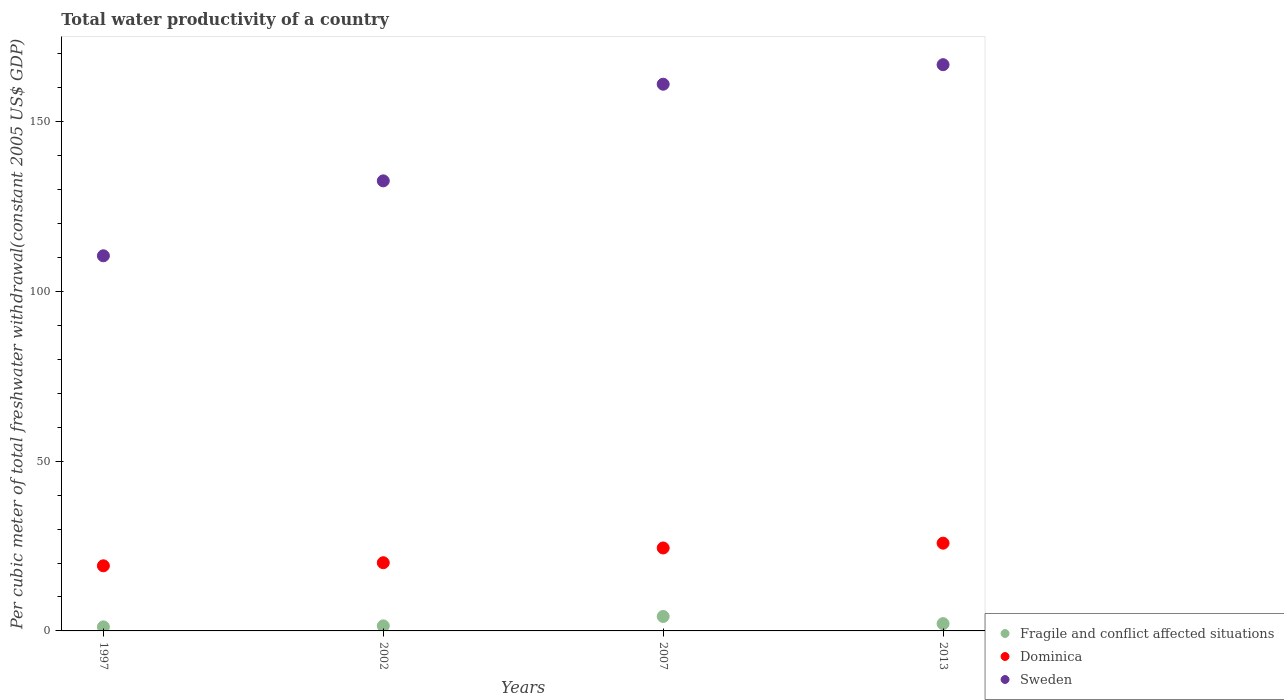What is the total water productivity in Sweden in 2002?
Your answer should be compact. 132.53. Across all years, what is the maximum total water productivity in Fragile and conflict affected situations?
Provide a short and direct response. 4.26. Across all years, what is the minimum total water productivity in Fragile and conflict affected situations?
Give a very brief answer. 1.2. In which year was the total water productivity in Fragile and conflict affected situations minimum?
Make the answer very short. 1997. What is the total total water productivity in Fragile and conflict affected situations in the graph?
Offer a very short reply. 9.08. What is the difference between the total water productivity in Sweden in 1997 and that in 2002?
Offer a very short reply. -22.07. What is the difference between the total water productivity in Fragile and conflict affected situations in 2002 and the total water productivity in Dominica in 1997?
Your response must be concise. -17.69. What is the average total water productivity in Dominica per year?
Make the answer very short. 22.38. In the year 2002, what is the difference between the total water productivity in Dominica and total water productivity in Sweden?
Provide a short and direct response. -112.45. What is the ratio of the total water productivity in Sweden in 2002 to that in 2007?
Keep it short and to the point. 0.82. Is the difference between the total water productivity in Dominica in 2002 and 2007 greater than the difference between the total water productivity in Sweden in 2002 and 2007?
Keep it short and to the point. Yes. What is the difference between the highest and the second highest total water productivity in Fragile and conflict affected situations?
Ensure brevity in your answer.  2.11. What is the difference between the highest and the lowest total water productivity in Dominica?
Your response must be concise. 6.66. In how many years, is the total water productivity in Dominica greater than the average total water productivity in Dominica taken over all years?
Ensure brevity in your answer.  2. Is it the case that in every year, the sum of the total water productivity in Fragile and conflict affected situations and total water productivity in Dominica  is greater than the total water productivity in Sweden?
Your answer should be very brief. No. Is the total water productivity in Dominica strictly greater than the total water productivity in Fragile and conflict affected situations over the years?
Offer a terse response. Yes. What is the difference between two consecutive major ticks on the Y-axis?
Your answer should be very brief. 50. Are the values on the major ticks of Y-axis written in scientific E-notation?
Offer a terse response. No. Where does the legend appear in the graph?
Ensure brevity in your answer.  Bottom right. What is the title of the graph?
Offer a terse response. Total water productivity of a country. What is the label or title of the Y-axis?
Provide a succinct answer. Per cubic meter of total freshwater withdrawal(constant 2005 US$ GDP). What is the Per cubic meter of total freshwater withdrawal(constant 2005 US$ GDP) of Fragile and conflict affected situations in 1997?
Your response must be concise. 1.2. What is the Per cubic meter of total freshwater withdrawal(constant 2005 US$ GDP) of Dominica in 1997?
Provide a short and direct response. 19.18. What is the Per cubic meter of total freshwater withdrawal(constant 2005 US$ GDP) of Sweden in 1997?
Your answer should be very brief. 110.46. What is the Per cubic meter of total freshwater withdrawal(constant 2005 US$ GDP) in Fragile and conflict affected situations in 2002?
Provide a short and direct response. 1.49. What is the Per cubic meter of total freshwater withdrawal(constant 2005 US$ GDP) of Dominica in 2002?
Offer a very short reply. 20.08. What is the Per cubic meter of total freshwater withdrawal(constant 2005 US$ GDP) in Sweden in 2002?
Ensure brevity in your answer.  132.53. What is the Per cubic meter of total freshwater withdrawal(constant 2005 US$ GDP) of Fragile and conflict affected situations in 2007?
Give a very brief answer. 4.26. What is the Per cubic meter of total freshwater withdrawal(constant 2005 US$ GDP) in Dominica in 2007?
Keep it short and to the point. 24.42. What is the Per cubic meter of total freshwater withdrawal(constant 2005 US$ GDP) in Sweden in 2007?
Offer a very short reply. 160.99. What is the Per cubic meter of total freshwater withdrawal(constant 2005 US$ GDP) of Fragile and conflict affected situations in 2013?
Your answer should be compact. 2.14. What is the Per cubic meter of total freshwater withdrawal(constant 2005 US$ GDP) in Dominica in 2013?
Keep it short and to the point. 25.84. What is the Per cubic meter of total freshwater withdrawal(constant 2005 US$ GDP) of Sweden in 2013?
Your response must be concise. 166.74. Across all years, what is the maximum Per cubic meter of total freshwater withdrawal(constant 2005 US$ GDP) of Fragile and conflict affected situations?
Offer a very short reply. 4.26. Across all years, what is the maximum Per cubic meter of total freshwater withdrawal(constant 2005 US$ GDP) in Dominica?
Your response must be concise. 25.84. Across all years, what is the maximum Per cubic meter of total freshwater withdrawal(constant 2005 US$ GDP) in Sweden?
Keep it short and to the point. 166.74. Across all years, what is the minimum Per cubic meter of total freshwater withdrawal(constant 2005 US$ GDP) of Fragile and conflict affected situations?
Provide a short and direct response. 1.2. Across all years, what is the minimum Per cubic meter of total freshwater withdrawal(constant 2005 US$ GDP) in Dominica?
Your response must be concise. 19.18. Across all years, what is the minimum Per cubic meter of total freshwater withdrawal(constant 2005 US$ GDP) of Sweden?
Make the answer very short. 110.46. What is the total Per cubic meter of total freshwater withdrawal(constant 2005 US$ GDP) of Fragile and conflict affected situations in the graph?
Keep it short and to the point. 9.08. What is the total Per cubic meter of total freshwater withdrawal(constant 2005 US$ GDP) of Dominica in the graph?
Provide a succinct answer. 89.53. What is the total Per cubic meter of total freshwater withdrawal(constant 2005 US$ GDP) in Sweden in the graph?
Offer a terse response. 570.73. What is the difference between the Per cubic meter of total freshwater withdrawal(constant 2005 US$ GDP) of Fragile and conflict affected situations in 1997 and that in 2002?
Provide a succinct answer. -0.29. What is the difference between the Per cubic meter of total freshwater withdrawal(constant 2005 US$ GDP) of Dominica in 1997 and that in 2002?
Your response must be concise. -0.91. What is the difference between the Per cubic meter of total freshwater withdrawal(constant 2005 US$ GDP) in Sweden in 1997 and that in 2002?
Your answer should be compact. -22.07. What is the difference between the Per cubic meter of total freshwater withdrawal(constant 2005 US$ GDP) of Fragile and conflict affected situations in 1997 and that in 2007?
Ensure brevity in your answer.  -3.06. What is the difference between the Per cubic meter of total freshwater withdrawal(constant 2005 US$ GDP) in Dominica in 1997 and that in 2007?
Your answer should be very brief. -5.25. What is the difference between the Per cubic meter of total freshwater withdrawal(constant 2005 US$ GDP) of Sweden in 1997 and that in 2007?
Provide a succinct answer. -50.53. What is the difference between the Per cubic meter of total freshwater withdrawal(constant 2005 US$ GDP) of Fragile and conflict affected situations in 1997 and that in 2013?
Offer a very short reply. -0.95. What is the difference between the Per cubic meter of total freshwater withdrawal(constant 2005 US$ GDP) of Dominica in 1997 and that in 2013?
Offer a very short reply. -6.66. What is the difference between the Per cubic meter of total freshwater withdrawal(constant 2005 US$ GDP) of Sweden in 1997 and that in 2013?
Your response must be concise. -56.28. What is the difference between the Per cubic meter of total freshwater withdrawal(constant 2005 US$ GDP) of Fragile and conflict affected situations in 2002 and that in 2007?
Keep it short and to the point. -2.77. What is the difference between the Per cubic meter of total freshwater withdrawal(constant 2005 US$ GDP) of Dominica in 2002 and that in 2007?
Ensure brevity in your answer.  -4.34. What is the difference between the Per cubic meter of total freshwater withdrawal(constant 2005 US$ GDP) in Sweden in 2002 and that in 2007?
Offer a terse response. -28.46. What is the difference between the Per cubic meter of total freshwater withdrawal(constant 2005 US$ GDP) in Fragile and conflict affected situations in 2002 and that in 2013?
Provide a succinct answer. -0.66. What is the difference between the Per cubic meter of total freshwater withdrawal(constant 2005 US$ GDP) of Dominica in 2002 and that in 2013?
Your answer should be compact. -5.76. What is the difference between the Per cubic meter of total freshwater withdrawal(constant 2005 US$ GDP) in Sweden in 2002 and that in 2013?
Your answer should be very brief. -34.21. What is the difference between the Per cubic meter of total freshwater withdrawal(constant 2005 US$ GDP) of Fragile and conflict affected situations in 2007 and that in 2013?
Your answer should be compact. 2.11. What is the difference between the Per cubic meter of total freshwater withdrawal(constant 2005 US$ GDP) of Dominica in 2007 and that in 2013?
Your answer should be very brief. -1.42. What is the difference between the Per cubic meter of total freshwater withdrawal(constant 2005 US$ GDP) in Sweden in 2007 and that in 2013?
Your answer should be very brief. -5.75. What is the difference between the Per cubic meter of total freshwater withdrawal(constant 2005 US$ GDP) of Fragile and conflict affected situations in 1997 and the Per cubic meter of total freshwater withdrawal(constant 2005 US$ GDP) of Dominica in 2002?
Make the answer very short. -18.89. What is the difference between the Per cubic meter of total freshwater withdrawal(constant 2005 US$ GDP) in Fragile and conflict affected situations in 1997 and the Per cubic meter of total freshwater withdrawal(constant 2005 US$ GDP) in Sweden in 2002?
Give a very brief answer. -131.34. What is the difference between the Per cubic meter of total freshwater withdrawal(constant 2005 US$ GDP) in Dominica in 1997 and the Per cubic meter of total freshwater withdrawal(constant 2005 US$ GDP) in Sweden in 2002?
Give a very brief answer. -113.35. What is the difference between the Per cubic meter of total freshwater withdrawal(constant 2005 US$ GDP) of Fragile and conflict affected situations in 1997 and the Per cubic meter of total freshwater withdrawal(constant 2005 US$ GDP) of Dominica in 2007?
Give a very brief answer. -23.23. What is the difference between the Per cubic meter of total freshwater withdrawal(constant 2005 US$ GDP) in Fragile and conflict affected situations in 1997 and the Per cubic meter of total freshwater withdrawal(constant 2005 US$ GDP) in Sweden in 2007?
Your answer should be very brief. -159.79. What is the difference between the Per cubic meter of total freshwater withdrawal(constant 2005 US$ GDP) in Dominica in 1997 and the Per cubic meter of total freshwater withdrawal(constant 2005 US$ GDP) in Sweden in 2007?
Ensure brevity in your answer.  -141.81. What is the difference between the Per cubic meter of total freshwater withdrawal(constant 2005 US$ GDP) of Fragile and conflict affected situations in 1997 and the Per cubic meter of total freshwater withdrawal(constant 2005 US$ GDP) of Dominica in 2013?
Your answer should be very brief. -24.65. What is the difference between the Per cubic meter of total freshwater withdrawal(constant 2005 US$ GDP) of Fragile and conflict affected situations in 1997 and the Per cubic meter of total freshwater withdrawal(constant 2005 US$ GDP) of Sweden in 2013?
Offer a terse response. -165.55. What is the difference between the Per cubic meter of total freshwater withdrawal(constant 2005 US$ GDP) of Dominica in 1997 and the Per cubic meter of total freshwater withdrawal(constant 2005 US$ GDP) of Sweden in 2013?
Your answer should be compact. -147.56. What is the difference between the Per cubic meter of total freshwater withdrawal(constant 2005 US$ GDP) in Fragile and conflict affected situations in 2002 and the Per cubic meter of total freshwater withdrawal(constant 2005 US$ GDP) in Dominica in 2007?
Give a very brief answer. -22.94. What is the difference between the Per cubic meter of total freshwater withdrawal(constant 2005 US$ GDP) in Fragile and conflict affected situations in 2002 and the Per cubic meter of total freshwater withdrawal(constant 2005 US$ GDP) in Sweden in 2007?
Provide a succinct answer. -159.5. What is the difference between the Per cubic meter of total freshwater withdrawal(constant 2005 US$ GDP) in Dominica in 2002 and the Per cubic meter of total freshwater withdrawal(constant 2005 US$ GDP) in Sweden in 2007?
Your answer should be compact. -140.91. What is the difference between the Per cubic meter of total freshwater withdrawal(constant 2005 US$ GDP) in Fragile and conflict affected situations in 2002 and the Per cubic meter of total freshwater withdrawal(constant 2005 US$ GDP) in Dominica in 2013?
Make the answer very short. -24.36. What is the difference between the Per cubic meter of total freshwater withdrawal(constant 2005 US$ GDP) in Fragile and conflict affected situations in 2002 and the Per cubic meter of total freshwater withdrawal(constant 2005 US$ GDP) in Sweden in 2013?
Ensure brevity in your answer.  -165.26. What is the difference between the Per cubic meter of total freshwater withdrawal(constant 2005 US$ GDP) of Dominica in 2002 and the Per cubic meter of total freshwater withdrawal(constant 2005 US$ GDP) of Sweden in 2013?
Your answer should be compact. -146.66. What is the difference between the Per cubic meter of total freshwater withdrawal(constant 2005 US$ GDP) of Fragile and conflict affected situations in 2007 and the Per cubic meter of total freshwater withdrawal(constant 2005 US$ GDP) of Dominica in 2013?
Keep it short and to the point. -21.58. What is the difference between the Per cubic meter of total freshwater withdrawal(constant 2005 US$ GDP) of Fragile and conflict affected situations in 2007 and the Per cubic meter of total freshwater withdrawal(constant 2005 US$ GDP) of Sweden in 2013?
Give a very brief answer. -162.48. What is the difference between the Per cubic meter of total freshwater withdrawal(constant 2005 US$ GDP) of Dominica in 2007 and the Per cubic meter of total freshwater withdrawal(constant 2005 US$ GDP) of Sweden in 2013?
Offer a terse response. -142.32. What is the average Per cubic meter of total freshwater withdrawal(constant 2005 US$ GDP) of Fragile and conflict affected situations per year?
Keep it short and to the point. 2.27. What is the average Per cubic meter of total freshwater withdrawal(constant 2005 US$ GDP) in Dominica per year?
Give a very brief answer. 22.38. What is the average Per cubic meter of total freshwater withdrawal(constant 2005 US$ GDP) in Sweden per year?
Provide a short and direct response. 142.68. In the year 1997, what is the difference between the Per cubic meter of total freshwater withdrawal(constant 2005 US$ GDP) in Fragile and conflict affected situations and Per cubic meter of total freshwater withdrawal(constant 2005 US$ GDP) in Dominica?
Provide a succinct answer. -17.98. In the year 1997, what is the difference between the Per cubic meter of total freshwater withdrawal(constant 2005 US$ GDP) in Fragile and conflict affected situations and Per cubic meter of total freshwater withdrawal(constant 2005 US$ GDP) in Sweden?
Your answer should be very brief. -109.27. In the year 1997, what is the difference between the Per cubic meter of total freshwater withdrawal(constant 2005 US$ GDP) of Dominica and Per cubic meter of total freshwater withdrawal(constant 2005 US$ GDP) of Sweden?
Your answer should be very brief. -91.29. In the year 2002, what is the difference between the Per cubic meter of total freshwater withdrawal(constant 2005 US$ GDP) of Fragile and conflict affected situations and Per cubic meter of total freshwater withdrawal(constant 2005 US$ GDP) of Dominica?
Keep it short and to the point. -18.6. In the year 2002, what is the difference between the Per cubic meter of total freshwater withdrawal(constant 2005 US$ GDP) in Fragile and conflict affected situations and Per cubic meter of total freshwater withdrawal(constant 2005 US$ GDP) in Sweden?
Offer a very short reply. -131.05. In the year 2002, what is the difference between the Per cubic meter of total freshwater withdrawal(constant 2005 US$ GDP) of Dominica and Per cubic meter of total freshwater withdrawal(constant 2005 US$ GDP) of Sweden?
Your answer should be very brief. -112.45. In the year 2007, what is the difference between the Per cubic meter of total freshwater withdrawal(constant 2005 US$ GDP) of Fragile and conflict affected situations and Per cubic meter of total freshwater withdrawal(constant 2005 US$ GDP) of Dominica?
Ensure brevity in your answer.  -20.17. In the year 2007, what is the difference between the Per cubic meter of total freshwater withdrawal(constant 2005 US$ GDP) in Fragile and conflict affected situations and Per cubic meter of total freshwater withdrawal(constant 2005 US$ GDP) in Sweden?
Keep it short and to the point. -156.73. In the year 2007, what is the difference between the Per cubic meter of total freshwater withdrawal(constant 2005 US$ GDP) of Dominica and Per cubic meter of total freshwater withdrawal(constant 2005 US$ GDP) of Sweden?
Keep it short and to the point. -136.56. In the year 2013, what is the difference between the Per cubic meter of total freshwater withdrawal(constant 2005 US$ GDP) of Fragile and conflict affected situations and Per cubic meter of total freshwater withdrawal(constant 2005 US$ GDP) of Dominica?
Your answer should be very brief. -23.7. In the year 2013, what is the difference between the Per cubic meter of total freshwater withdrawal(constant 2005 US$ GDP) of Fragile and conflict affected situations and Per cubic meter of total freshwater withdrawal(constant 2005 US$ GDP) of Sweden?
Make the answer very short. -164.6. In the year 2013, what is the difference between the Per cubic meter of total freshwater withdrawal(constant 2005 US$ GDP) in Dominica and Per cubic meter of total freshwater withdrawal(constant 2005 US$ GDP) in Sweden?
Give a very brief answer. -140.9. What is the ratio of the Per cubic meter of total freshwater withdrawal(constant 2005 US$ GDP) of Fragile and conflict affected situations in 1997 to that in 2002?
Make the answer very short. 0.8. What is the ratio of the Per cubic meter of total freshwater withdrawal(constant 2005 US$ GDP) in Dominica in 1997 to that in 2002?
Your response must be concise. 0.95. What is the ratio of the Per cubic meter of total freshwater withdrawal(constant 2005 US$ GDP) in Sweden in 1997 to that in 2002?
Make the answer very short. 0.83. What is the ratio of the Per cubic meter of total freshwater withdrawal(constant 2005 US$ GDP) of Fragile and conflict affected situations in 1997 to that in 2007?
Your answer should be very brief. 0.28. What is the ratio of the Per cubic meter of total freshwater withdrawal(constant 2005 US$ GDP) in Dominica in 1997 to that in 2007?
Provide a short and direct response. 0.79. What is the ratio of the Per cubic meter of total freshwater withdrawal(constant 2005 US$ GDP) of Sweden in 1997 to that in 2007?
Your response must be concise. 0.69. What is the ratio of the Per cubic meter of total freshwater withdrawal(constant 2005 US$ GDP) of Fragile and conflict affected situations in 1997 to that in 2013?
Offer a very short reply. 0.56. What is the ratio of the Per cubic meter of total freshwater withdrawal(constant 2005 US$ GDP) of Dominica in 1997 to that in 2013?
Your response must be concise. 0.74. What is the ratio of the Per cubic meter of total freshwater withdrawal(constant 2005 US$ GDP) in Sweden in 1997 to that in 2013?
Your response must be concise. 0.66. What is the ratio of the Per cubic meter of total freshwater withdrawal(constant 2005 US$ GDP) of Fragile and conflict affected situations in 2002 to that in 2007?
Your answer should be very brief. 0.35. What is the ratio of the Per cubic meter of total freshwater withdrawal(constant 2005 US$ GDP) in Dominica in 2002 to that in 2007?
Your response must be concise. 0.82. What is the ratio of the Per cubic meter of total freshwater withdrawal(constant 2005 US$ GDP) of Sweden in 2002 to that in 2007?
Your answer should be compact. 0.82. What is the ratio of the Per cubic meter of total freshwater withdrawal(constant 2005 US$ GDP) of Fragile and conflict affected situations in 2002 to that in 2013?
Give a very brief answer. 0.69. What is the ratio of the Per cubic meter of total freshwater withdrawal(constant 2005 US$ GDP) in Dominica in 2002 to that in 2013?
Your answer should be very brief. 0.78. What is the ratio of the Per cubic meter of total freshwater withdrawal(constant 2005 US$ GDP) of Sweden in 2002 to that in 2013?
Your answer should be compact. 0.79. What is the ratio of the Per cubic meter of total freshwater withdrawal(constant 2005 US$ GDP) in Fragile and conflict affected situations in 2007 to that in 2013?
Make the answer very short. 1.99. What is the ratio of the Per cubic meter of total freshwater withdrawal(constant 2005 US$ GDP) in Dominica in 2007 to that in 2013?
Offer a very short reply. 0.95. What is the ratio of the Per cubic meter of total freshwater withdrawal(constant 2005 US$ GDP) in Sweden in 2007 to that in 2013?
Your answer should be compact. 0.97. What is the difference between the highest and the second highest Per cubic meter of total freshwater withdrawal(constant 2005 US$ GDP) of Fragile and conflict affected situations?
Offer a terse response. 2.11. What is the difference between the highest and the second highest Per cubic meter of total freshwater withdrawal(constant 2005 US$ GDP) of Dominica?
Offer a very short reply. 1.42. What is the difference between the highest and the second highest Per cubic meter of total freshwater withdrawal(constant 2005 US$ GDP) of Sweden?
Offer a terse response. 5.75. What is the difference between the highest and the lowest Per cubic meter of total freshwater withdrawal(constant 2005 US$ GDP) in Fragile and conflict affected situations?
Make the answer very short. 3.06. What is the difference between the highest and the lowest Per cubic meter of total freshwater withdrawal(constant 2005 US$ GDP) in Dominica?
Offer a terse response. 6.66. What is the difference between the highest and the lowest Per cubic meter of total freshwater withdrawal(constant 2005 US$ GDP) in Sweden?
Provide a short and direct response. 56.28. 